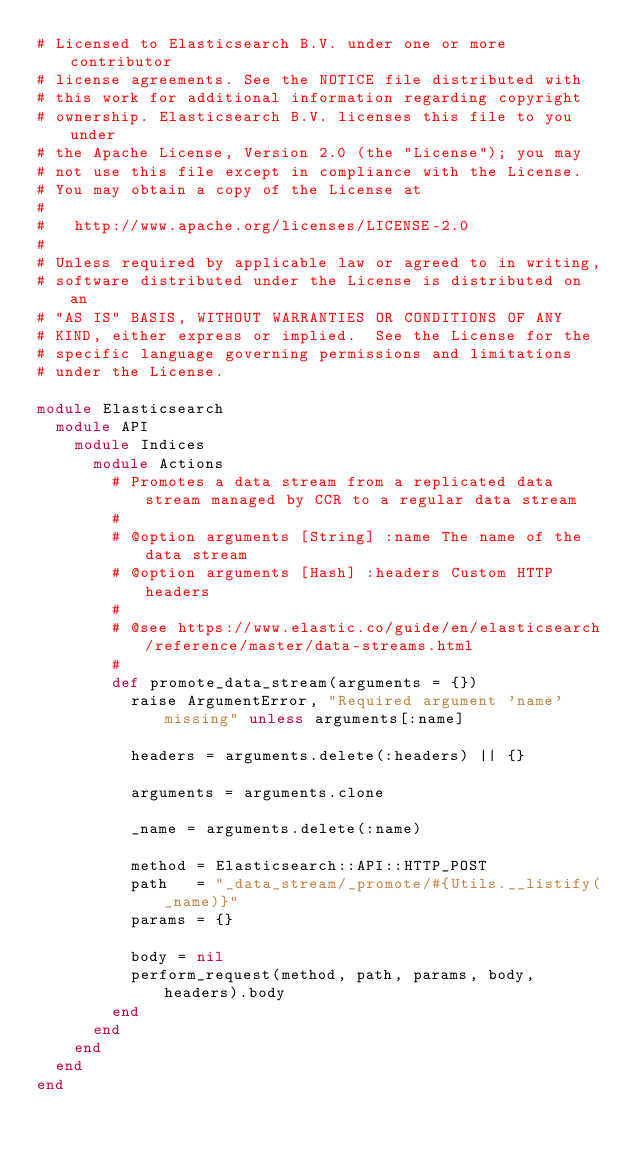<code> <loc_0><loc_0><loc_500><loc_500><_Ruby_># Licensed to Elasticsearch B.V. under one or more contributor
# license agreements. See the NOTICE file distributed with
# this work for additional information regarding copyright
# ownership. Elasticsearch B.V. licenses this file to you under
# the Apache License, Version 2.0 (the "License"); you may
# not use this file except in compliance with the License.
# You may obtain a copy of the License at
#
#   http://www.apache.org/licenses/LICENSE-2.0
#
# Unless required by applicable law or agreed to in writing,
# software distributed under the License is distributed on an
# "AS IS" BASIS, WITHOUT WARRANTIES OR CONDITIONS OF ANY
# KIND, either express or implied.  See the License for the
# specific language governing permissions and limitations
# under the License.

module Elasticsearch
  module API
    module Indices
      module Actions
        # Promotes a data stream from a replicated data stream managed by CCR to a regular data stream
        #
        # @option arguments [String] :name The name of the data stream
        # @option arguments [Hash] :headers Custom HTTP headers
        #
        # @see https://www.elastic.co/guide/en/elasticsearch/reference/master/data-streams.html
        #
        def promote_data_stream(arguments = {})
          raise ArgumentError, "Required argument 'name' missing" unless arguments[:name]

          headers = arguments.delete(:headers) || {}

          arguments = arguments.clone

          _name = arguments.delete(:name)

          method = Elasticsearch::API::HTTP_POST
          path   = "_data_stream/_promote/#{Utils.__listify(_name)}"
          params = {}

          body = nil
          perform_request(method, path, params, body, headers).body
        end
      end
    end
  end
end
</code> 